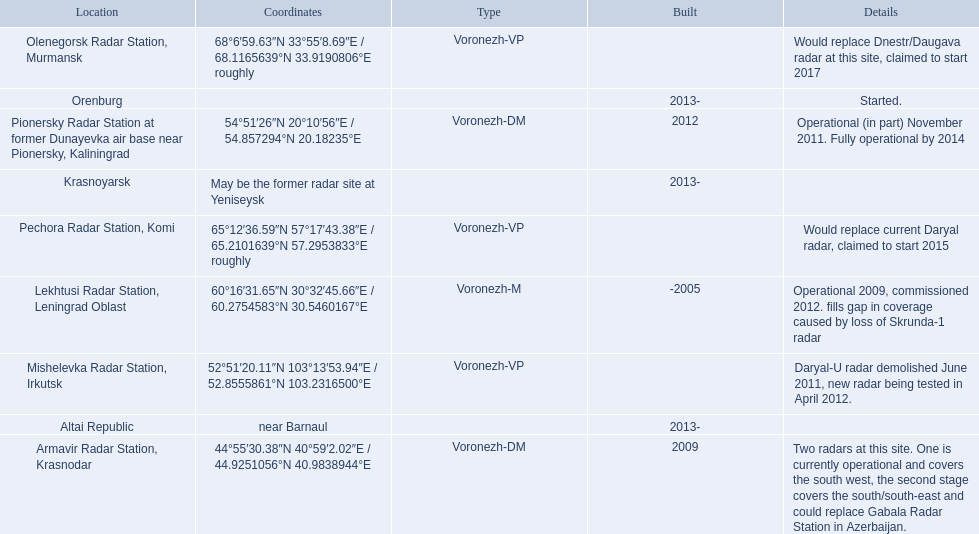Which voronezh radar has already started? Orenburg. Which radar would replace dnestr/daugava? Olenegorsk Radar Station, Murmansk. Which radar started in 2015? Pechora Radar Station, Komi. 